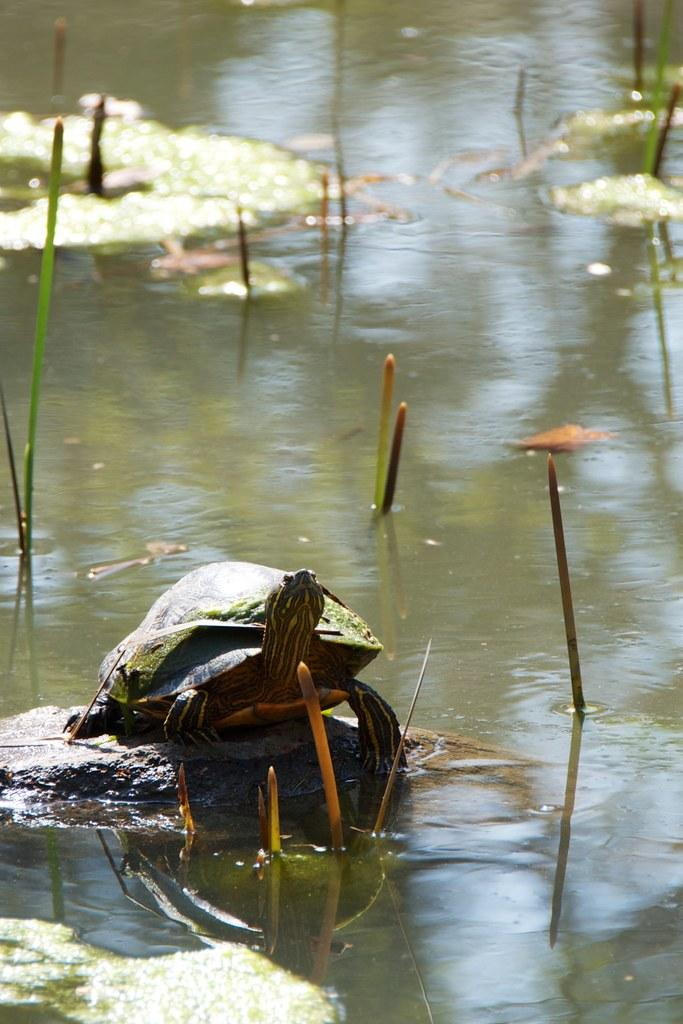What animal is on a rock in the image? There is a tortoise on a rock in the image. What can be seen in the water body in the image? There are plants in a water body in the image. What type of knot is the tortoise using to climb the rock in the image? The tortoise is not using a knot to climb the rock in the image; it is simply resting on the rock. 